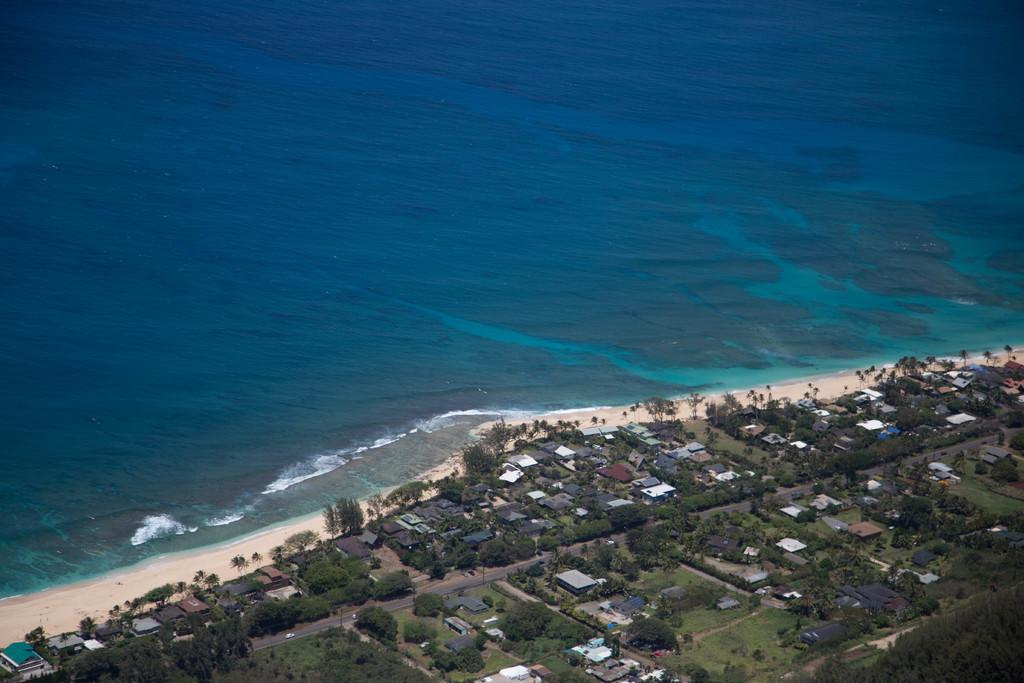What type of view is shown in the image? The image is an aerial view of a city. What can be seen in the foreground of the image? In the foreground, there are trees, grass, fields, houses, sand, a beach, and various objects. What is located at the top of the image? There is a water body at the top of the image. What type of shoes can be seen on the mother in the image? There is no mother or shoes present in the image. The image is an aerial view of a city, and no people are visible. 